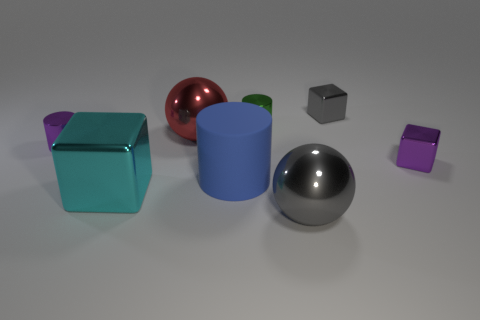Add 1 large cyan things. How many objects exist? 9 Subtract all blocks. How many objects are left? 5 Add 5 cyan objects. How many cyan objects exist? 6 Subtract 0 blue blocks. How many objects are left? 8 Subtract all big gray objects. Subtract all brown metal blocks. How many objects are left? 7 Add 4 big matte cylinders. How many big matte cylinders are left? 5 